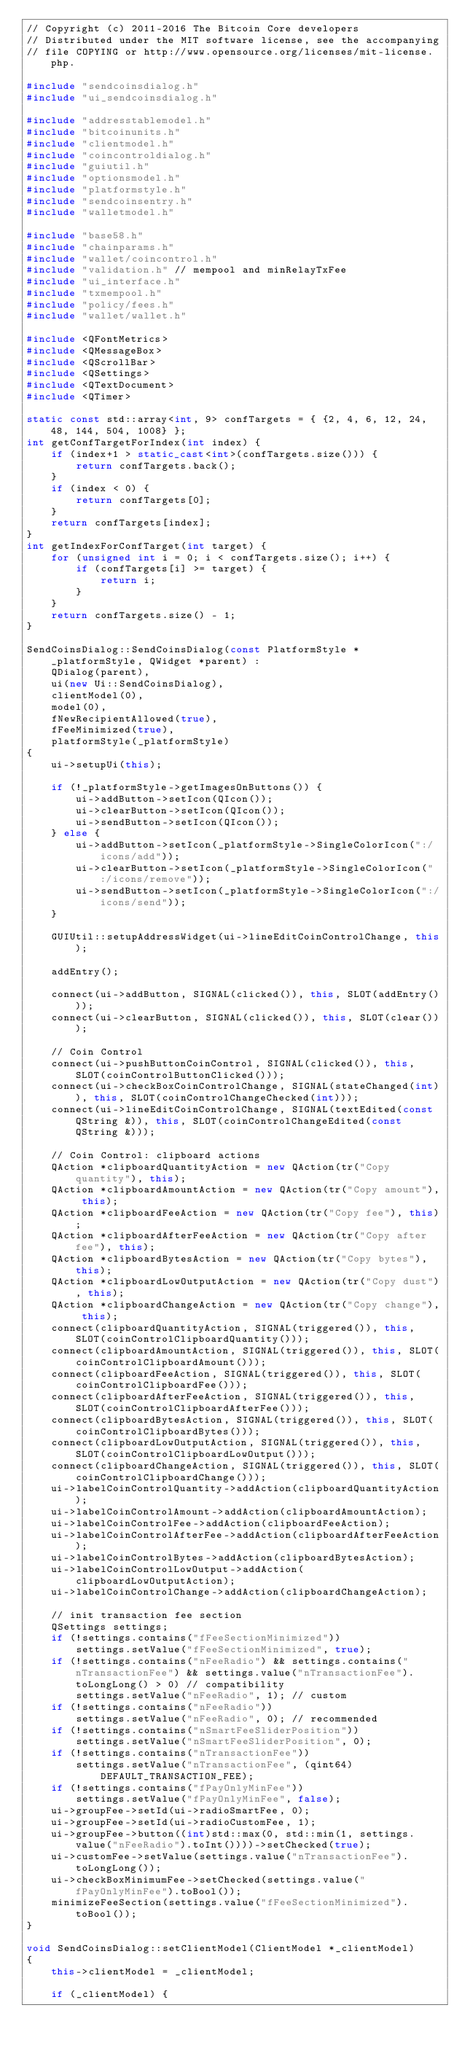Convert code to text. <code><loc_0><loc_0><loc_500><loc_500><_C++_>// Copyright (c) 2011-2016 The Bitcoin Core developers
// Distributed under the MIT software license, see the accompanying
// file COPYING or http://www.opensource.org/licenses/mit-license.php.

#include "sendcoinsdialog.h"
#include "ui_sendcoinsdialog.h"

#include "addresstablemodel.h"
#include "bitcoinunits.h"
#include "clientmodel.h"
#include "coincontroldialog.h"
#include "guiutil.h"
#include "optionsmodel.h"
#include "platformstyle.h"
#include "sendcoinsentry.h"
#include "walletmodel.h"

#include "base58.h"
#include "chainparams.h"
#include "wallet/coincontrol.h"
#include "validation.h" // mempool and minRelayTxFee
#include "ui_interface.h"
#include "txmempool.h"
#include "policy/fees.h"
#include "wallet/wallet.h"

#include <QFontMetrics>
#include <QMessageBox>
#include <QScrollBar>
#include <QSettings>
#include <QTextDocument>
#include <QTimer>

static const std::array<int, 9> confTargets = { {2, 4, 6, 12, 24, 48, 144, 504, 1008} };
int getConfTargetForIndex(int index) {
    if (index+1 > static_cast<int>(confTargets.size())) {
        return confTargets.back();
    }
    if (index < 0) {
        return confTargets[0];
    }
    return confTargets[index];
}
int getIndexForConfTarget(int target) {
    for (unsigned int i = 0; i < confTargets.size(); i++) {
        if (confTargets[i] >= target) {
            return i;
        }
    }
    return confTargets.size() - 1;
}

SendCoinsDialog::SendCoinsDialog(const PlatformStyle *_platformStyle, QWidget *parent) :
    QDialog(parent),
    ui(new Ui::SendCoinsDialog),
    clientModel(0),
    model(0),
    fNewRecipientAllowed(true),
    fFeeMinimized(true),
    platformStyle(_platformStyle)
{
    ui->setupUi(this);

    if (!_platformStyle->getImagesOnButtons()) {
        ui->addButton->setIcon(QIcon());
        ui->clearButton->setIcon(QIcon());
        ui->sendButton->setIcon(QIcon());
    } else {
        ui->addButton->setIcon(_platformStyle->SingleColorIcon(":/icons/add"));
        ui->clearButton->setIcon(_platformStyle->SingleColorIcon(":/icons/remove"));
        ui->sendButton->setIcon(_platformStyle->SingleColorIcon(":/icons/send"));
    }

    GUIUtil::setupAddressWidget(ui->lineEditCoinControlChange, this);

    addEntry();

    connect(ui->addButton, SIGNAL(clicked()), this, SLOT(addEntry()));
    connect(ui->clearButton, SIGNAL(clicked()), this, SLOT(clear()));

    // Coin Control
    connect(ui->pushButtonCoinControl, SIGNAL(clicked()), this, SLOT(coinControlButtonClicked()));
    connect(ui->checkBoxCoinControlChange, SIGNAL(stateChanged(int)), this, SLOT(coinControlChangeChecked(int)));
    connect(ui->lineEditCoinControlChange, SIGNAL(textEdited(const QString &)), this, SLOT(coinControlChangeEdited(const QString &)));

    // Coin Control: clipboard actions
    QAction *clipboardQuantityAction = new QAction(tr("Copy quantity"), this);
    QAction *clipboardAmountAction = new QAction(tr("Copy amount"), this);
    QAction *clipboardFeeAction = new QAction(tr("Copy fee"), this);
    QAction *clipboardAfterFeeAction = new QAction(tr("Copy after fee"), this);
    QAction *clipboardBytesAction = new QAction(tr("Copy bytes"), this);
    QAction *clipboardLowOutputAction = new QAction(tr("Copy dust"), this);
    QAction *clipboardChangeAction = new QAction(tr("Copy change"), this);
    connect(clipboardQuantityAction, SIGNAL(triggered()), this, SLOT(coinControlClipboardQuantity()));
    connect(clipboardAmountAction, SIGNAL(triggered()), this, SLOT(coinControlClipboardAmount()));
    connect(clipboardFeeAction, SIGNAL(triggered()), this, SLOT(coinControlClipboardFee()));
    connect(clipboardAfterFeeAction, SIGNAL(triggered()), this, SLOT(coinControlClipboardAfterFee()));
    connect(clipboardBytesAction, SIGNAL(triggered()), this, SLOT(coinControlClipboardBytes()));
    connect(clipboardLowOutputAction, SIGNAL(triggered()), this, SLOT(coinControlClipboardLowOutput()));
    connect(clipboardChangeAction, SIGNAL(triggered()), this, SLOT(coinControlClipboardChange()));
    ui->labelCoinControlQuantity->addAction(clipboardQuantityAction);
    ui->labelCoinControlAmount->addAction(clipboardAmountAction);
    ui->labelCoinControlFee->addAction(clipboardFeeAction);
    ui->labelCoinControlAfterFee->addAction(clipboardAfterFeeAction);
    ui->labelCoinControlBytes->addAction(clipboardBytesAction);
    ui->labelCoinControlLowOutput->addAction(clipboardLowOutputAction);
    ui->labelCoinControlChange->addAction(clipboardChangeAction);

    // init transaction fee section
    QSettings settings;
    if (!settings.contains("fFeeSectionMinimized"))
        settings.setValue("fFeeSectionMinimized", true);
    if (!settings.contains("nFeeRadio") && settings.contains("nTransactionFee") && settings.value("nTransactionFee").toLongLong() > 0) // compatibility
        settings.setValue("nFeeRadio", 1); // custom
    if (!settings.contains("nFeeRadio"))
        settings.setValue("nFeeRadio", 0); // recommended
    if (!settings.contains("nSmartFeeSliderPosition"))
        settings.setValue("nSmartFeeSliderPosition", 0);
    if (!settings.contains("nTransactionFee"))
        settings.setValue("nTransactionFee", (qint64)DEFAULT_TRANSACTION_FEE);
    if (!settings.contains("fPayOnlyMinFee"))
        settings.setValue("fPayOnlyMinFee", false);
    ui->groupFee->setId(ui->radioSmartFee, 0);
    ui->groupFee->setId(ui->radioCustomFee, 1);
    ui->groupFee->button((int)std::max(0, std::min(1, settings.value("nFeeRadio").toInt())))->setChecked(true);
    ui->customFee->setValue(settings.value("nTransactionFee").toLongLong());
    ui->checkBoxMinimumFee->setChecked(settings.value("fPayOnlyMinFee").toBool());
    minimizeFeeSection(settings.value("fFeeSectionMinimized").toBool());
}

void SendCoinsDialog::setClientModel(ClientModel *_clientModel)
{
    this->clientModel = _clientModel;

    if (_clientModel) {</code> 